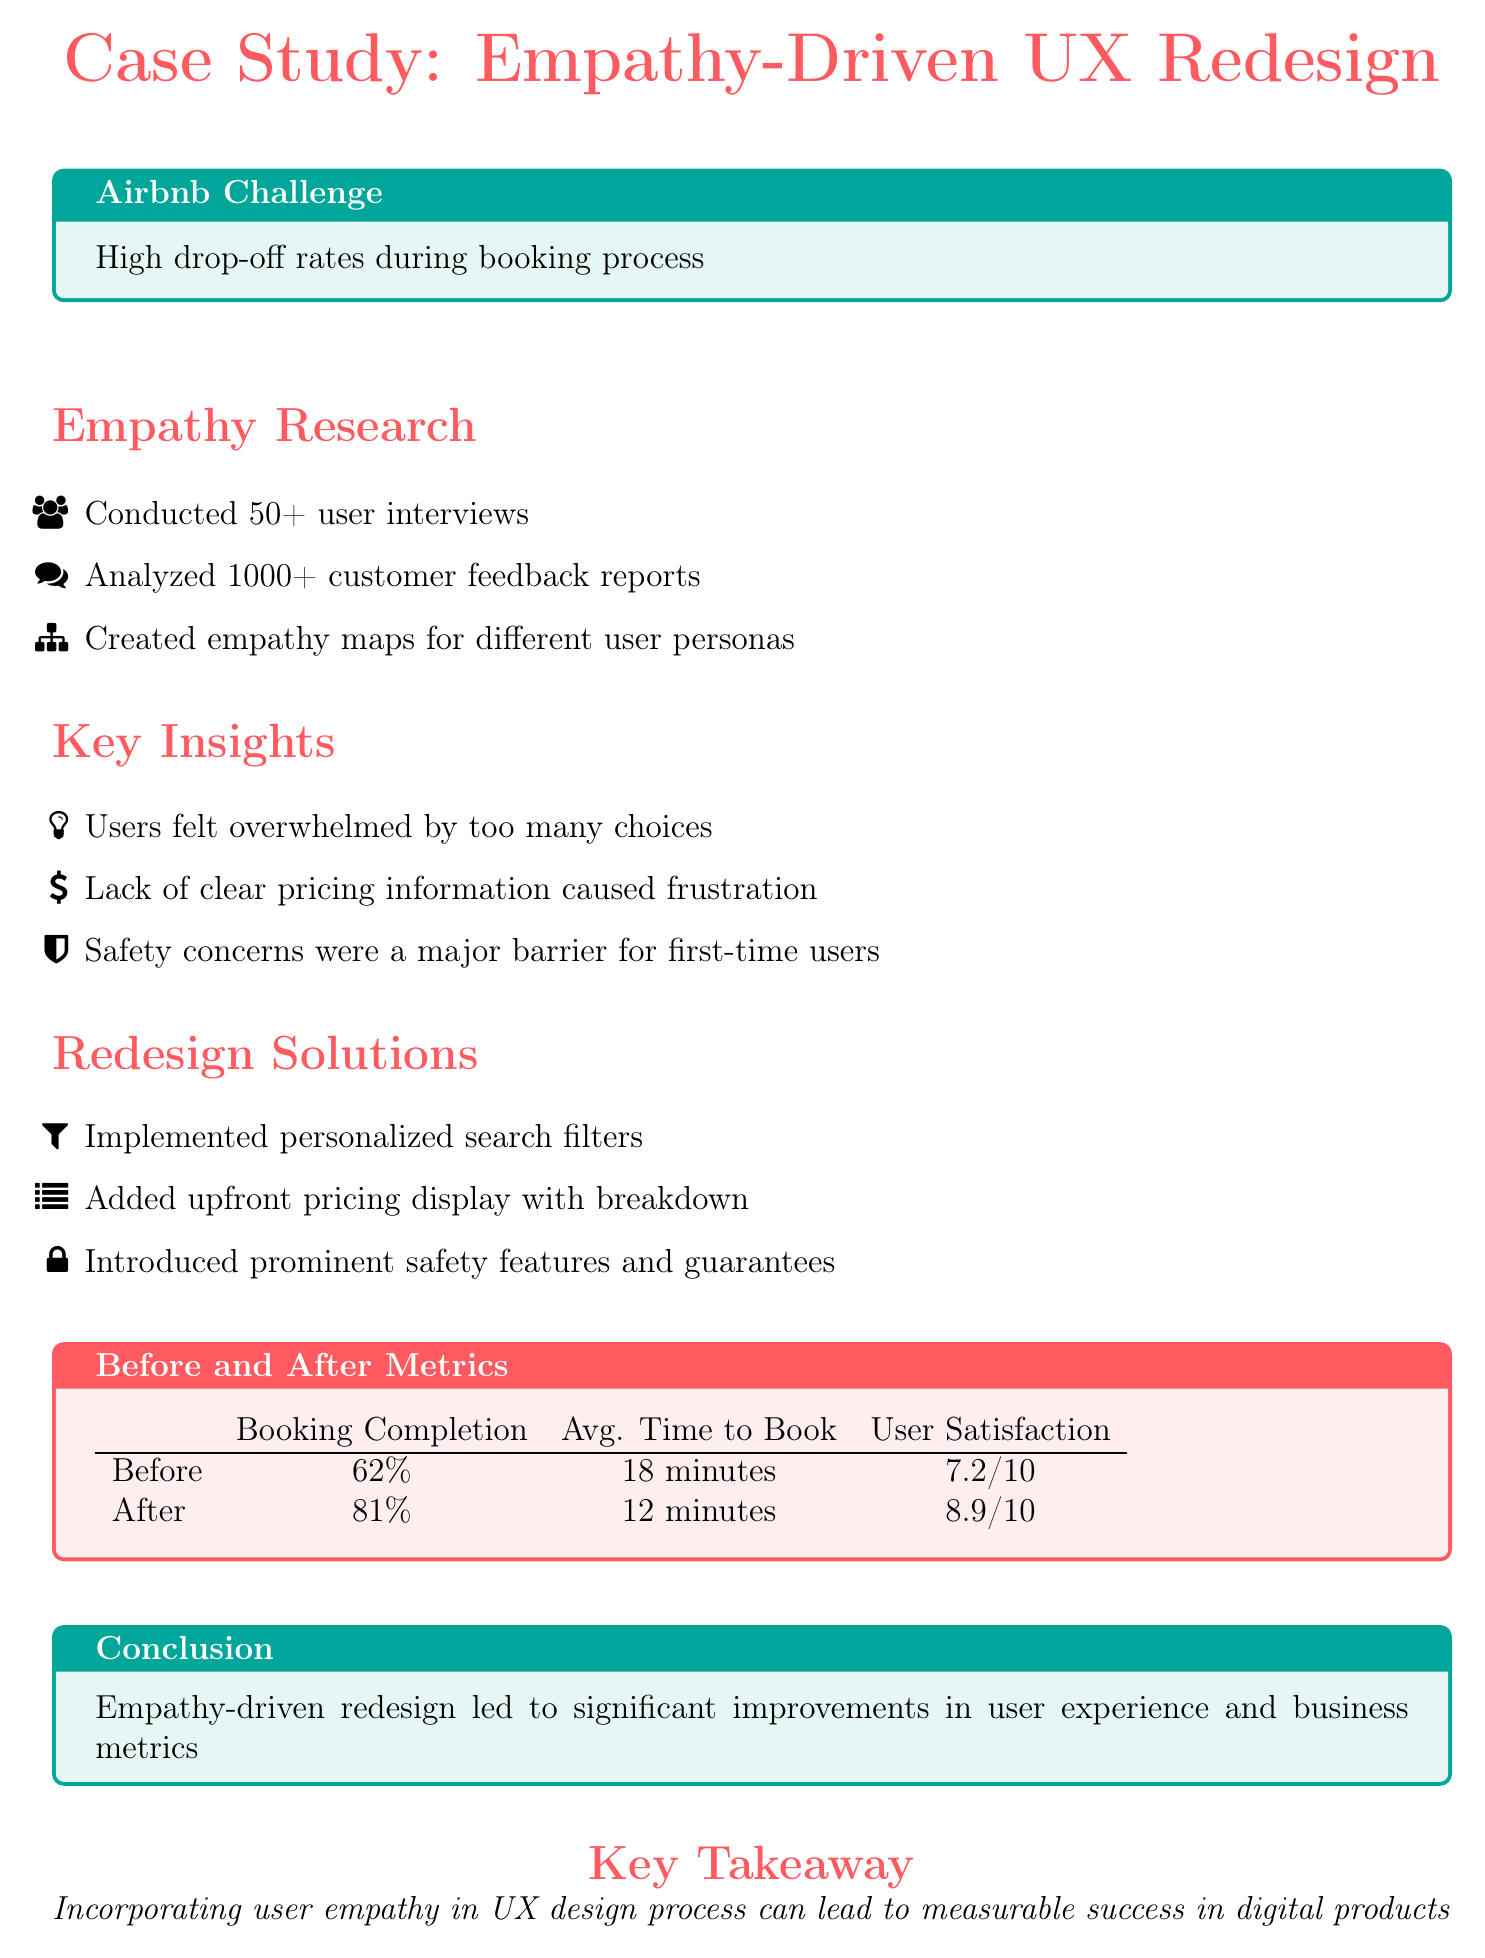What was the booking completion percentage before the redesign? The booking completion percentage before the redesign is stated in the before-and-after metrics section of the document.
Answer: 62% What key insight was related to user choices? The key insight regarding user choices identifies that users felt overwhelmed by too many choices, found in the key insights section.
Answer: Overwhelmed by too many choices How many user interviews were conducted? The number of user interviews conducted is mentioned in the empathy research section of the document.
Answer: 50+ What was the average time to book after the redesign? The average time to book after the redesign is detailed in the before and after metrics section of the document.
Answer: 12 minutes What safety feature was introduced in the redesign? The introduction of safety features is outlined in the redesign solutions section, mentioning prominent safety features and guarantees.
Answer: Prominent safety features What was the user satisfaction rating before the redesign? The user satisfaction rating before the redesign can be found in the before and after metrics table.
Answer: 7.2/10 How many customer feedback reports were analyzed? The document specifies the number of customer feedback reports analyzed within the empathy research section.
Answer: 1000+ What is the primary focus of the case study? The primary focus of the case study is highlighted in the title and throughout the document regarding improvements in user experience through empathy.
Answer: Empathy-driven UX redesign What conclusion is drawn from the redesign metrics? The conclusion summarizes the results of the redesign in terms of improvements in user experience and business metrics, found in the conclusion box.
Answer: Significant improvements in user experience and business metrics 